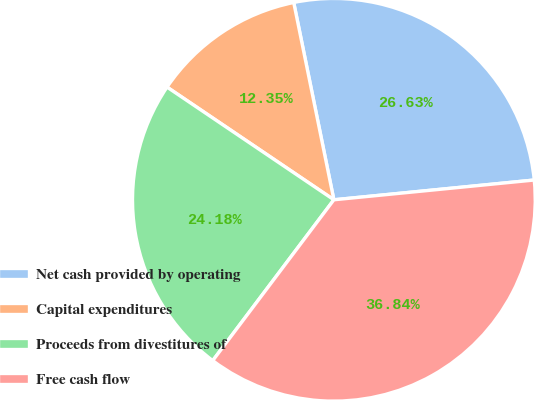Convert chart. <chart><loc_0><loc_0><loc_500><loc_500><pie_chart><fcel>Net cash provided by operating<fcel>Capital expenditures<fcel>Proceeds from divestitures of<fcel>Free cash flow<nl><fcel>26.63%<fcel>12.35%<fcel>24.18%<fcel>36.84%<nl></chart> 